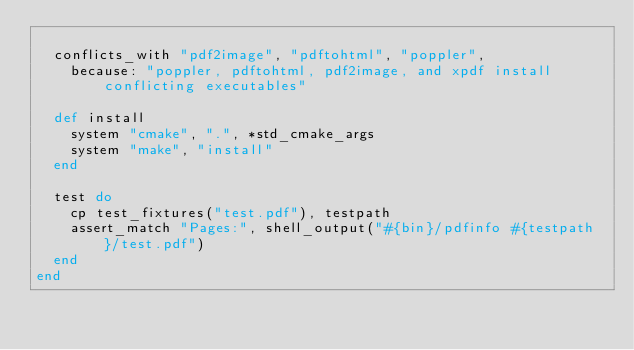<code> <loc_0><loc_0><loc_500><loc_500><_Ruby_>
  conflicts_with "pdf2image", "pdftohtml", "poppler",
    because: "poppler, pdftohtml, pdf2image, and xpdf install conflicting executables"

  def install
    system "cmake", ".", *std_cmake_args
    system "make", "install"
  end

  test do
    cp test_fixtures("test.pdf"), testpath
    assert_match "Pages:", shell_output("#{bin}/pdfinfo #{testpath}/test.pdf")
  end
end
</code> 